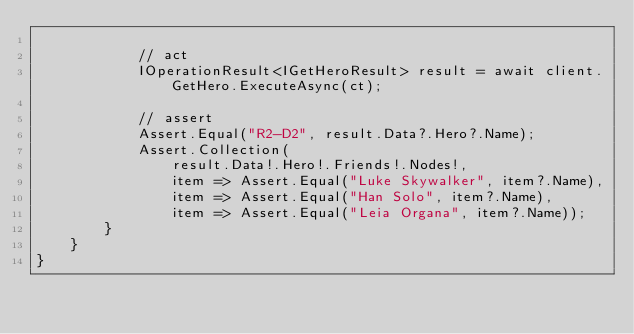Convert code to text. <code><loc_0><loc_0><loc_500><loc_500><_C#_>
            // act
            IOperationResult<IGetHeroResult> result = await client.GetHero.ExecuteAsync(ct);

            // assert
            Assert.Equal("R2-D2", result.Data?.Hero?.Name);
            Assert.Collection(
                result.Data!.Hero!.Friends!.Nodes!,
                item => Assert.Equal("Luke Skywalker", item?.Name),
                item => Assert.Equal("Han Solo", item?.Name),
                item => Assert.Equal("Leia Organa", item?.Name));
        }
    }
}
</code> 